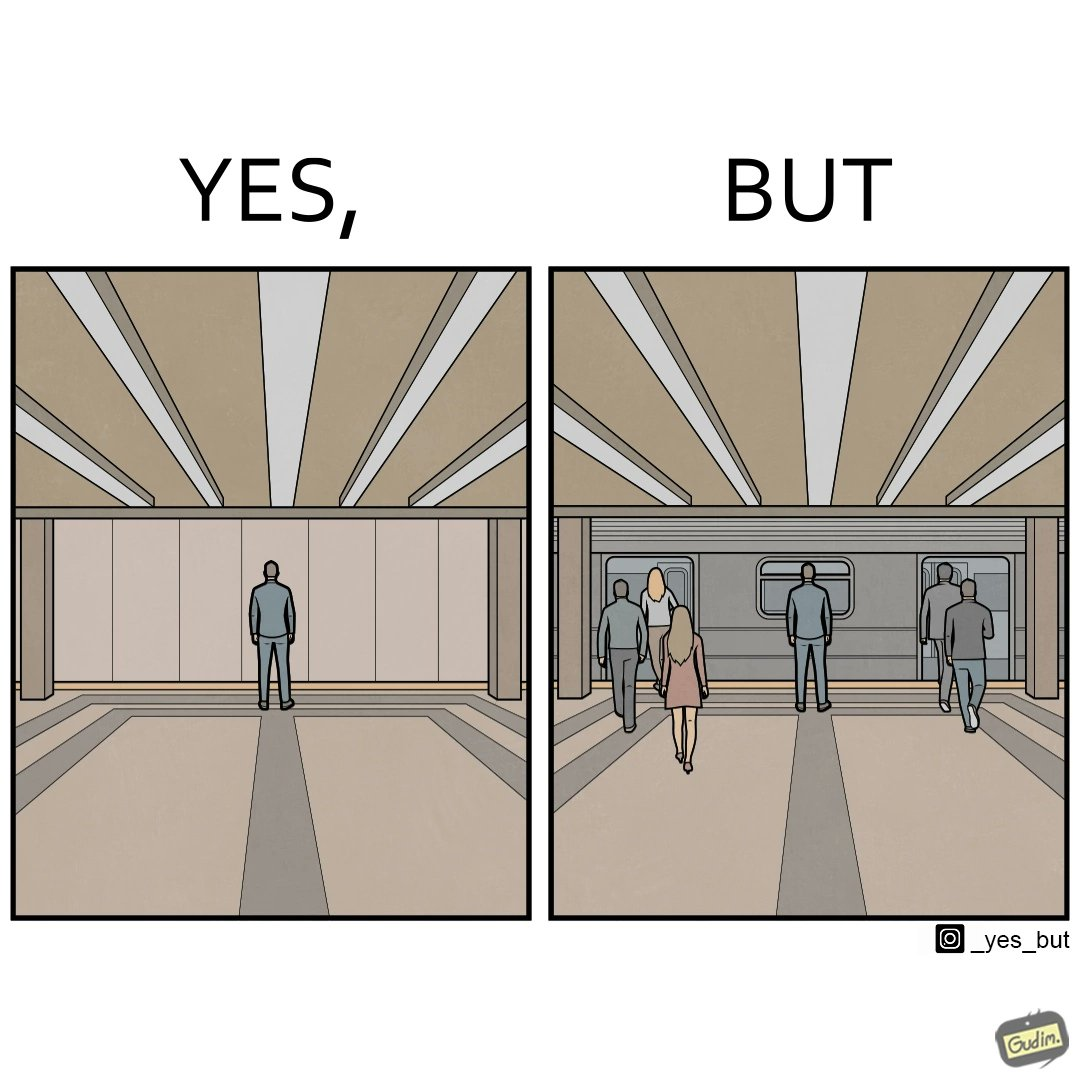Compare the left and right sides of this image. In the left part of the image: it seems the person is standing in an empty room In the right part of the image: it seems the image of a railway or metro station, where everyone is boarding the train except one person 